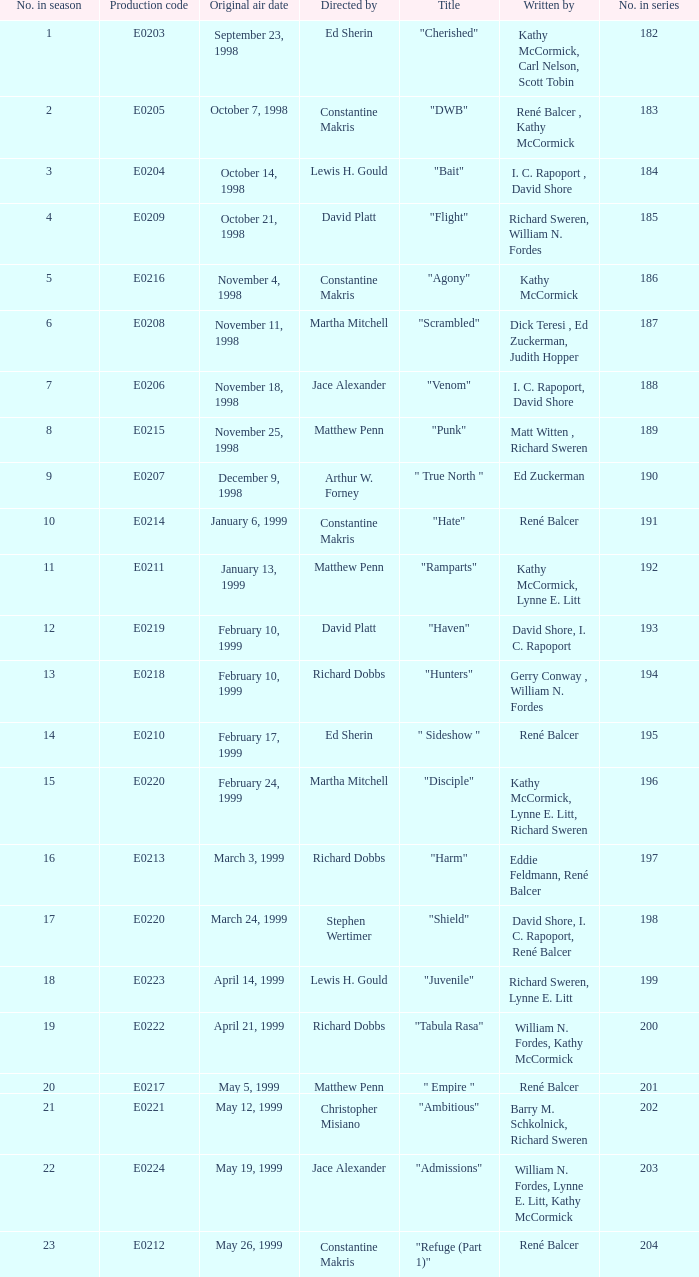The episode with the production code E0208 is directed by who? Martha Mitchell. Can you give me this table as a dict? {'header': ['No. in season', 'Production code', 'Original air date', 'Directed by', 'Title', 'Written by', 'No. in series'], 'rows': [['1', 'E0203', 'September 23, 1998', 'Ed Sherin', '"Cherished"', 'Kathy McCormick, Carl Nelson, Scott Tobin', '182'], ['2', 'E0205', 'October 7, 1998', 'Constantine Makris', '"DWB"', 'René Balcer , Kathy McCormick', '183'], ['3', 'E0204', 'October 14, 1998', 'Lewis H. Gould', '"Bait"', 'I. C. Rapoport , David Shore', '184'], ['4', 'E0209', 'October 21, 1998', 'David Platt', '"Flight"', 'Richard Sweren, William N. Fordes', '185'], ['5', 'E0216', 'November 4, 1998', 'Constantine Makris', '"Agony"', 'Kathy McCormick', '186'], ['6', 'E0208', 'November 11, 1998', 'Martha Mitchell', '"Scrambled"', 'Dick Teresi , Ed Zuckerman, Judith Hopper', '187'], ['7', 'E0206', 'November 18, 1998', 'Jace Alexander', '"Venom"', 'I. C. Rapoport, David Shore', '188'], ['8', 'E0215', 'November 25, 1998', 'Matthew Penn', '"Punk"', 'Matt Witten , Richard Sweren', '189'], ['9', 'E0207', 'December 9, 1998', 'Arthur W. Forney', '" True North "', 'Ed Zuckerman', '190'], ['10', 'E0214', 'January 6, 1999', 'Constantine Makris', '"Hate"', 'René Balcer', '191'], ['11', 'E0211', 'January 13, 1999', 'Matthew Penn', '"Ramparts"', 'Kathy McCormick, Lynne E. Litt', '192'], ['12', 'E0219', 'February 10, 1999', 'David Platt', '"Haven"', 'David Shore, I. C. Rapoport', '193'], ['13', 'E0218', 'February 10, 1999', 'Richard Dobbs', '"Hunters"', 'Gerry Conway , William N. Fordes', '194'], ['14', 'E0210', 'February 17, 1999', 'Ed Sherin', '" Sideshow "', 'René Balcer', '195'], ['15', 'E0220', 'February 24, 1999', 'Martha Mitchell', '"Disciple"', 'Kathy McCormick, Lynne E. Litt, Richard Sweren', '196'], ['16', 'E0213', 'March 3, 1999', 'Richard Dobbs', '"Harm"', 'Eddie Feldmann, René Balcer', '197'], ['17', 'E0220', 'March 24, 1999', 'Stephen Wertimer', '"Shield"', 'David Shore, I. C. Rapoport, René Balcer', '198'], ['18', 'E0223', 'April 14, 1999', 'Lewis H. Gould', '"Juvenile"', 'Richard Sweren, Lynne E. Litt', '199'], ['19', 'E0222', 'April 21, 1999', 'Richard Dobbs', '"Tabula Rasa"', 'William N. Fordes, Kathy McCormick', '200'], ['20', 'E0217', 'May 5, 1999', 'Matthew Penn', '" Empire "', 'René Balcer', '201'], ['21', 'E0221', 'May 12, 1999', 'Christopher Misiano', '"Ambitious"', 'Barry M. Schkolnick, Richard Sweren', '202'], ['22', 'E0224', 'May 19, 1999', 'Jace Alexander', '"Admissions"', 'William N. Fordes, Lynne E. Litt, Kathy McCormick', '203'], ['23', 'E0212', 'May 26, 1999', 'Constantine Makris', '"Refuge (Part 1)"', 'René Balcer', '204']]} 